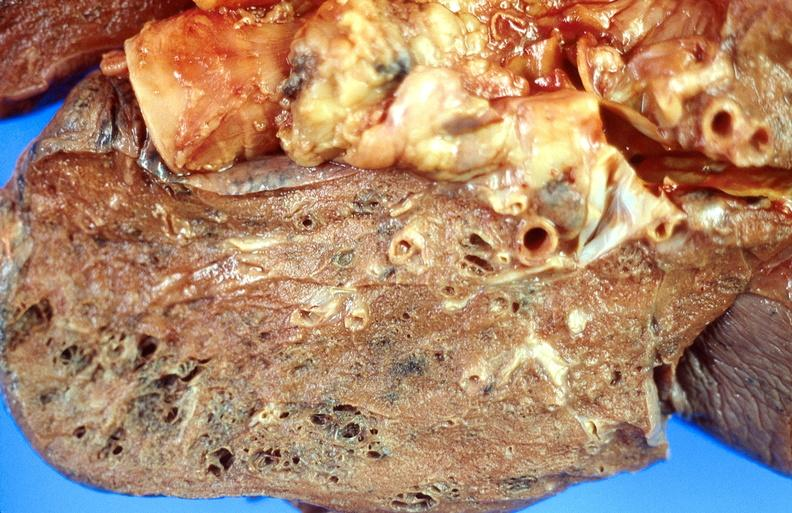what is present?
Answer the question using a single word or phrase. Respiratory 